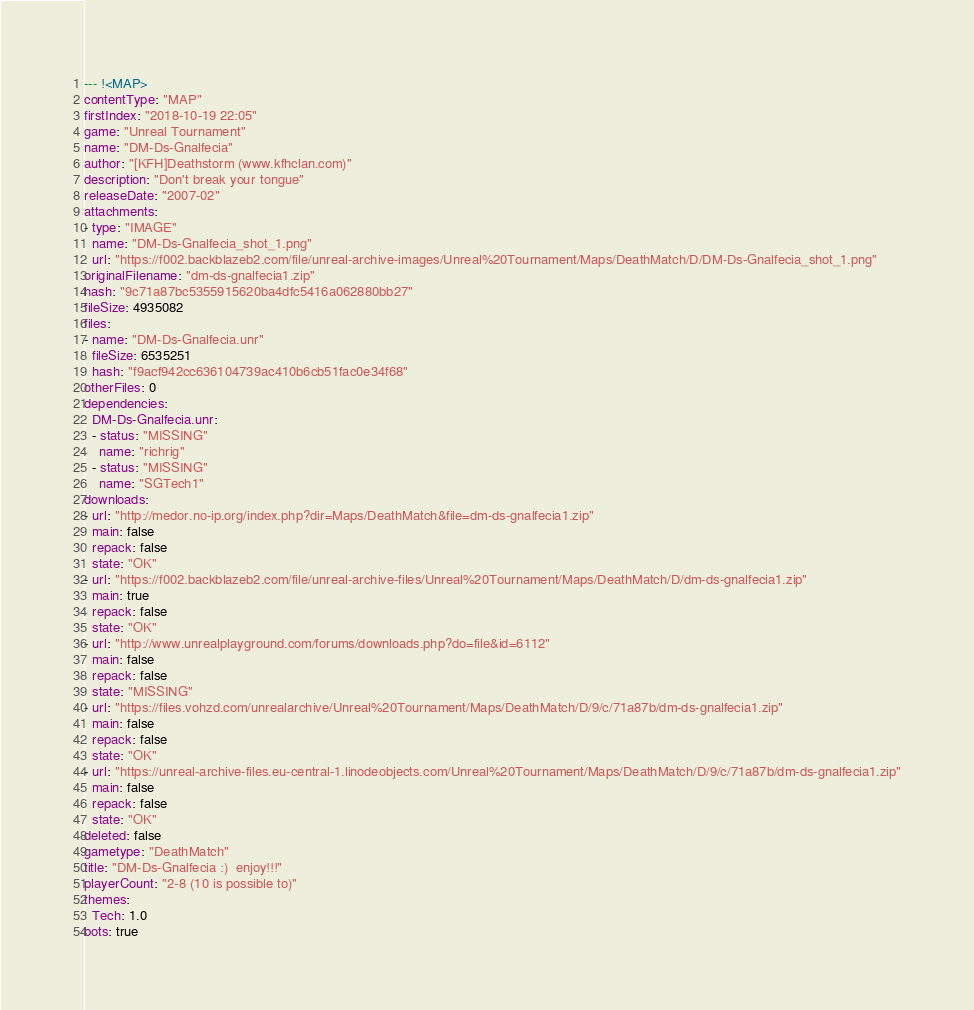Convert code to text. <code><loc_0><loc_0><loc_500><loc_500><_YAML_>--- !<MAP>
contentType: "MAP"
firstIndex: "2018-10-19 22:05"
game: "Unreal Tournament"
name: "DM-Ds-Gnalfecia"
author: "[KFH]Deathstorm (www.kfhclan.com)"
description: "Don't break your tongue"
releaseDate: "2007-02"
attachments:
- type: "IMAGE"
  name: "DM-Ds-Gnalfecia_shot_1.png"
  url: "https://f002.backblazeb2.com/file/unreal-archive-images/Unreal%20Tournament/Maps/DeathMatch/D/DM-Ds-Gnalfecia_shot_1.png"
originalFilename: "dm-ds-gnalfecia1.zip"
hash: "9c71a87bc5355915620ba4dfc5416a062880bb27"
fileSize: 4935082
files:
- name: "DM-Ds-Gnalfecia.unr"
  fileSize: 6535251
  hash: "f9acf942cc636104739ac410b6cb51fac0e34f68"
otherFiles: 0
dependencies:
  DM-Ds-Gnalfecia.unr:
  - status: "MISSING"
    name: "richrig"
  - status: "MISSING"
    name: "SGTech1"
downloads:
- url: "http://medor.no-ip.org/index.php?dir=Maps/DeathMatch&file=dm-ds-gnalfecia1.zip"
  main: false
  repack: false
  state: "OK"
- url: "https://f002.backblazeb2.com/file/unreal-archive-files/Unreal%20Tournament/Maps/DeathMatch/D/dm-ds-gnalfecia1.zip"
  main: true
  repack: false
  state: "OK"
- url: "http://www.unrealplayground.com/forums/downloads.php?do=file&id=6112"
  main: false
  repack: false
  state: "MISSING"
- url: "https://files.vohzd.com/unrealarchive/Unreal%20Tournament/Maps/DeathMatch/D/9/c/71a87b/dm-ds-gnalfecia1.zip"
  main: false
  repack: false
  state: "OK"
- url: "https://unreal-archive-files.eu-central-1.linodeobjects.com/Unreal%20Tournament/Maps/DeathMatch/D/9/c/71a87b/dm-ds-gnalfecia1.zip"
  main: false
  repack: false
  state: "OK"
deleted: false
gametype: "DeathMatch"
title: "DM-Ds-Gnalfecia :)  enjoy!!!"
playerCount: "2-8 (10 is possible to)"
themes:
  Tech: 1.0
bots: true
</code> 